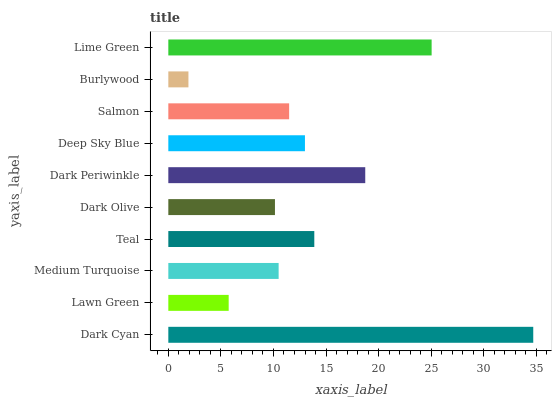Is Burlywood the minimum?
Answer yes or no. Yes. Is Dark Cyan the maximum?
Answer yes or no. Yes. Is Lawn Green the minimum?
Answer yes or no. No. Is Lawn Green the maximum?
Answer yes or no. No. Is Dark Cyan greater than Lawn Green?
Answer yes or no. Yes. Is Lawn Green less than Dark Cyan?
Answer yes or no. Yes. Is Lawn Green greater than Dark Cyan?
Answer yes or no. No. Is Dark Cyan less than Lawn Green?
Answer yes or no. No. Is Deep Sky Blue the high median?
Answer yes or no. Yes. Is Salmon the low median?
Answer yes or no. Yes. Is Dark Periwinkle the high median?
Answer yes or no. No. Is Burlywood the low median?
Answer yes or no. No. 